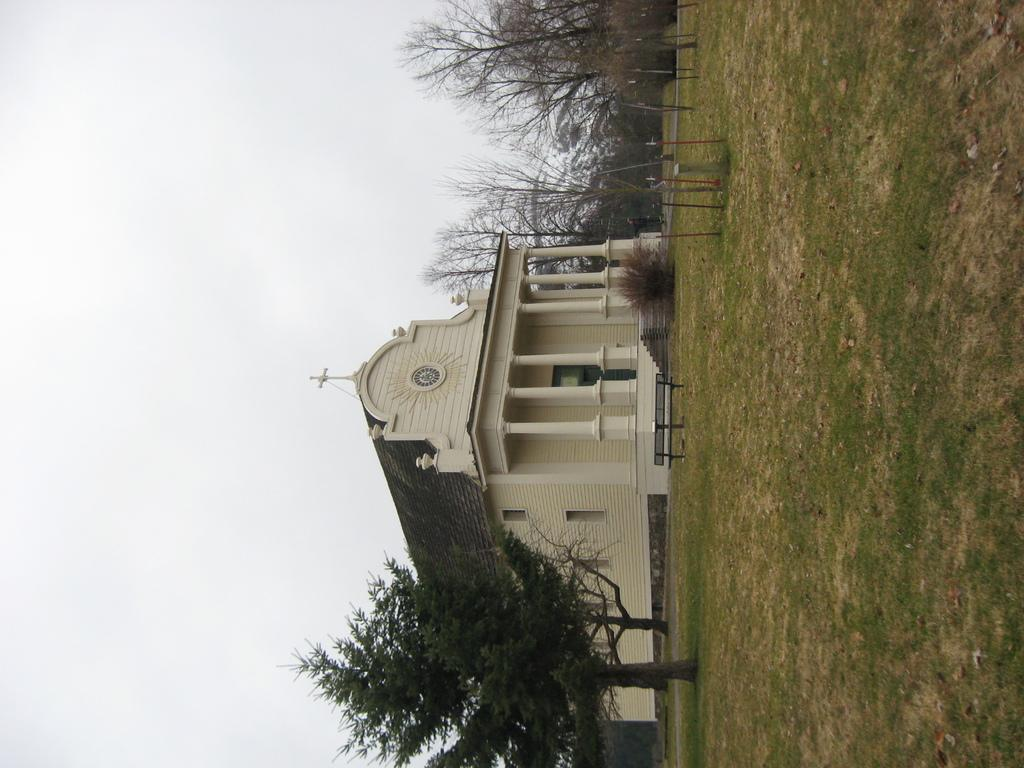What type of building is in the image? There is a chapel in the image. What type of vegetation is present in the image? There are trees in the image. What type of seating is available in the image? There is a bench in the image. What type of ground surface is visible in the image? There is grass on the ground in the image. What is the condition of the sky in the image? The sky is cloudy in the image. What flavor of toy can be seen on the bench in the image? There is no toy present in the image, and therefore no flavor can be associated with it. 